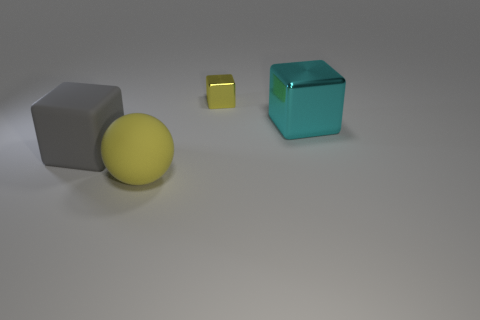Add 2 large blue things. How many objects exist? 6 Subtract all cubes. How many objects are left? 1 Subtract all large gray rubber cubes. Subtract all cyan shiny things. How many objects are left? 2 Add 1 large matte objects. How many large matte objects are left? 3 Add 2 cyan cubes. How many cyan cubes exist? 3 Subtract 0 brown cylinders. How many objects are left? 4 